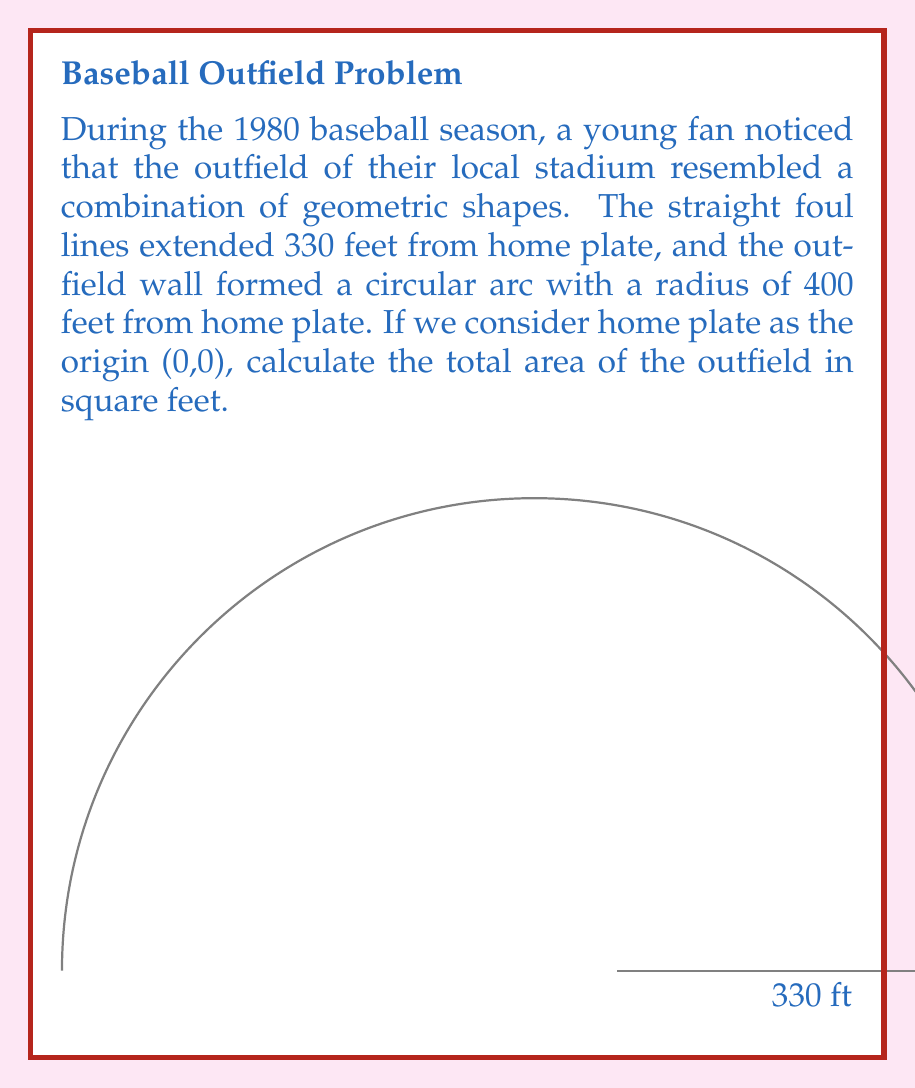Can you solve this math problem? Let's approach this step-by-step:

1) The outfield can be divided into two shapes: a circular sector and an isosceles triangle.

2) For the isosceles triangle:
   - Base = 2 * 330 = 660 feet
   - Height = $\sqrt{400^2 - 330^2} = \sqrt{160000 - 108900} = \sqrt{51100} \approx 226$ feet
   - Area of triangle = $\frac{1}{2} * 660 * 226 = 74580$ sq ft

3) For the circular sector:
   - Radius = 400 feet
   - Central angle = $2 * \arccos(\frac{330}{400}) = 2 * 0.6435 = 1.287$ radians
   - Area of sector = $\frac{1}{2} * 400^2 * 1.287 = 102960$ sq ft

4) Total area:
   $A_{total} = A_{triangle} + A_{sector} = 74580 + 102960 = 177540$ sq ft

Therefore, the total area of the outfield is approximately 177,540 square feet.
Answer: 177,540 sq ft 